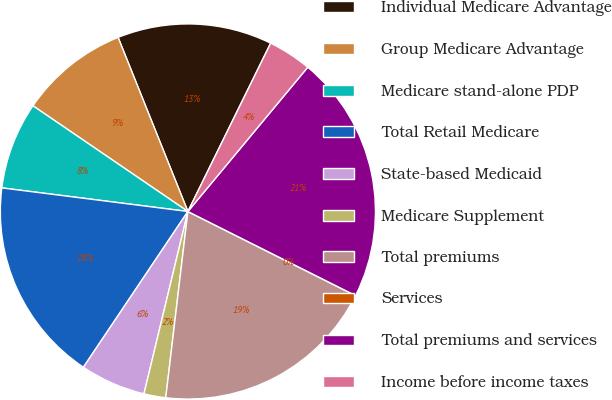<chart> <loc_0><loc_0><loc_500><loc_500><pie_chart><fcel>Individual Medicare Advantage<fcel>Group Medicare Advantage<fcel>Medicare stand-alone PDP<fcel>Total Retail Medicare<fcel>State-based Medicaid<fcel>Medicare Supplement<fcel>Total premiums<fcel>Services<fcel>Total premiums and services<fcel>Income before income taxes<nl><fcel>13.34%<fcel>9.4%<fcel>7.52%<fcel>17.6%<fcel>5.64%<fcel>1.88%<fcel>19.48%<fcel>0.0%<fcel>21.36%<fcel>3.76%<nl></chart> 